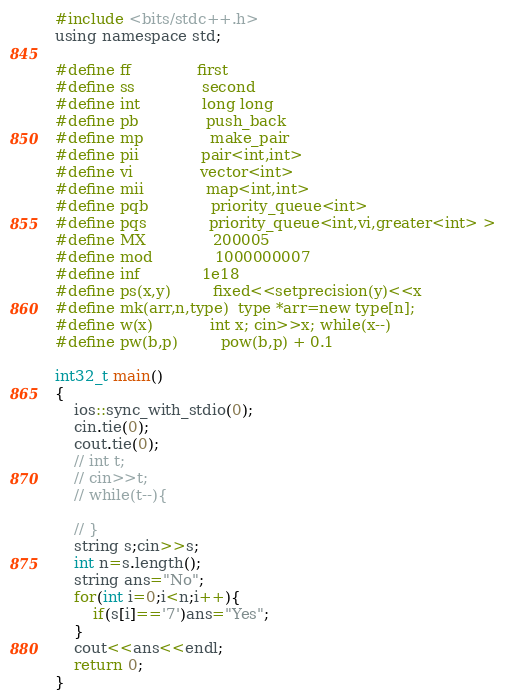Convert code to text. <code><loc_0><loc_0><loc_500><loc_500><_C_>#include <bits/stdc++.h>
using namespace std;

#define ff              first
#define ss              second
#define int             long long
#define pb              push_back
#define mp              make_pair
#define pii             pair<int,int>
#define vi              vector<int>
#define mii             map<int,int>
#define pqb             priority_queue<int>
#define pqs             priority_queue<int,vi,greater<int> >
#define MX              200005
#define mod             1000000007
#define inf             1e18
#define ps(x,y)         fixed<<setprecision(y)<<x
#define mk(arr,n,type)  type *arr=new type[n];
#define w(x)            int x; cin>>x; while(x--)
#define pw(b,p)         pow(b,p) + 0.1

int32_t main()
{
    ios::sync_with_stdio(0);
    cin.tie(0);
    cout.tie(0);
    // int t;
    // cin>>t;
    // while(t--){
        
    // }
    string s;cin>>s;
    int n=s.length();
    string ans="No";
    for(int i=0;i<n;i++){
        if(s[i]=='7')ans="Yes";
    }
    cout<<ans<<endl;
    return 0;
}</code> 